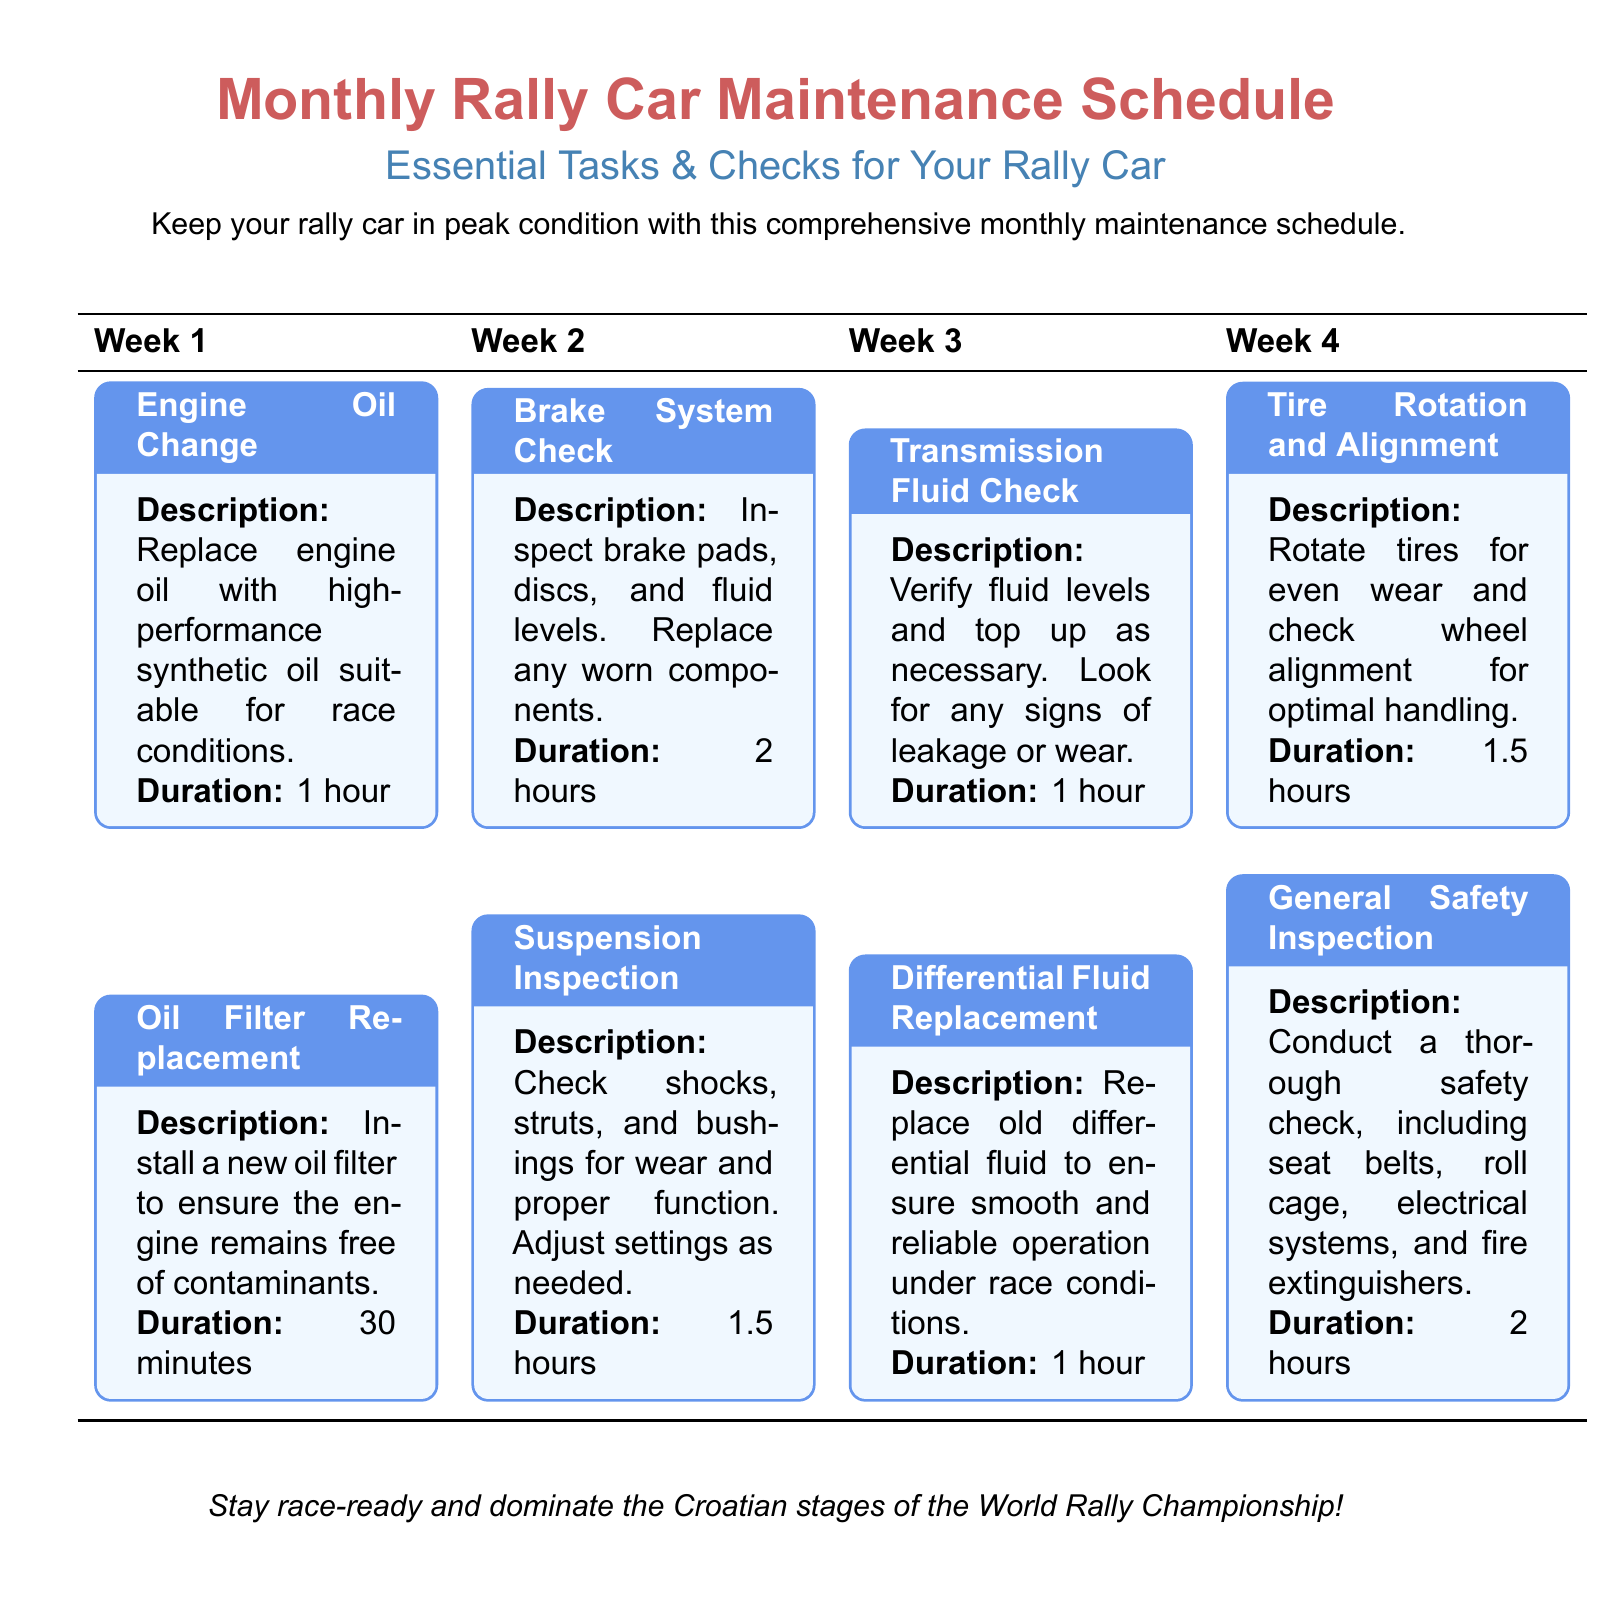What is the first maintenance task listed? The first maintenance task is mentioned in Week 1, which is the Engine Oil Change.
Answer: Engine Oil Change How long does the Brake System Check take? The time duration for the Brake System Check is provided as 2 hours.
Answer: 2 hours What is checked during the Suspension Inspection? The Suspension Inspection involves checking shocks, struts, and bushings for wear and proper function.
Answer: Shocks, struts, and bushings Which week includes the General Safety Inspection? The General Safety Inspection is scheduled for Week 4 as stated in the document.
Answer: Week 4 What maintenance task has the shortest duration? The Oil Filter Replacement is specified to take only 30 minutes.
Answer: 30 minutes How many tasks are scheduled for Week 3? There are three maintenance tasks listed for Week 3 in the document.
Answer: Three tasks What type of oil should be used for the Engine Oil Change? The document specifies the use of high-performance synthetic oil for the engine.
Answer: High-performance synthetic oil What is the purpose of the Tire Rotation and Alignment task? The task aims to ensure even wear and optimal handling of the tires.
Answer: Even wear and optimal handling What aspect of the rally car does the Differential Fluid Replacement pertain to? The Differential Fluid Replacement relates to the operation of the differential under race conditions.
Answer: Differential operation 